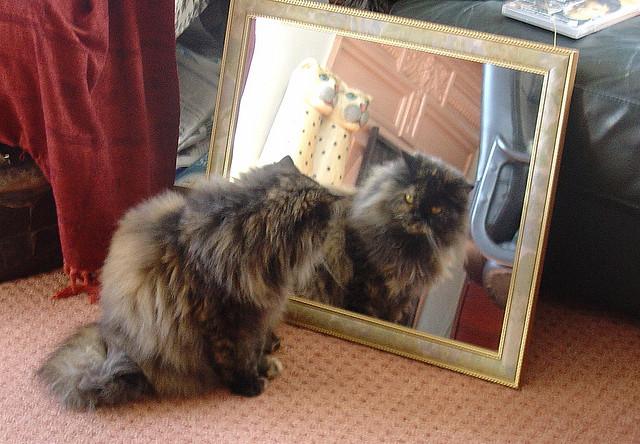Is there a dog?
Answer briefly. No. What is the color of the cat's hair?
Answer briefly. Brown. What is the mood of the cat?
Concise answer only. Curious. Is the cat enjoying sitting there?
Concise answer only. Yes. What color is the cat?
Be succinct. Brown and black. 